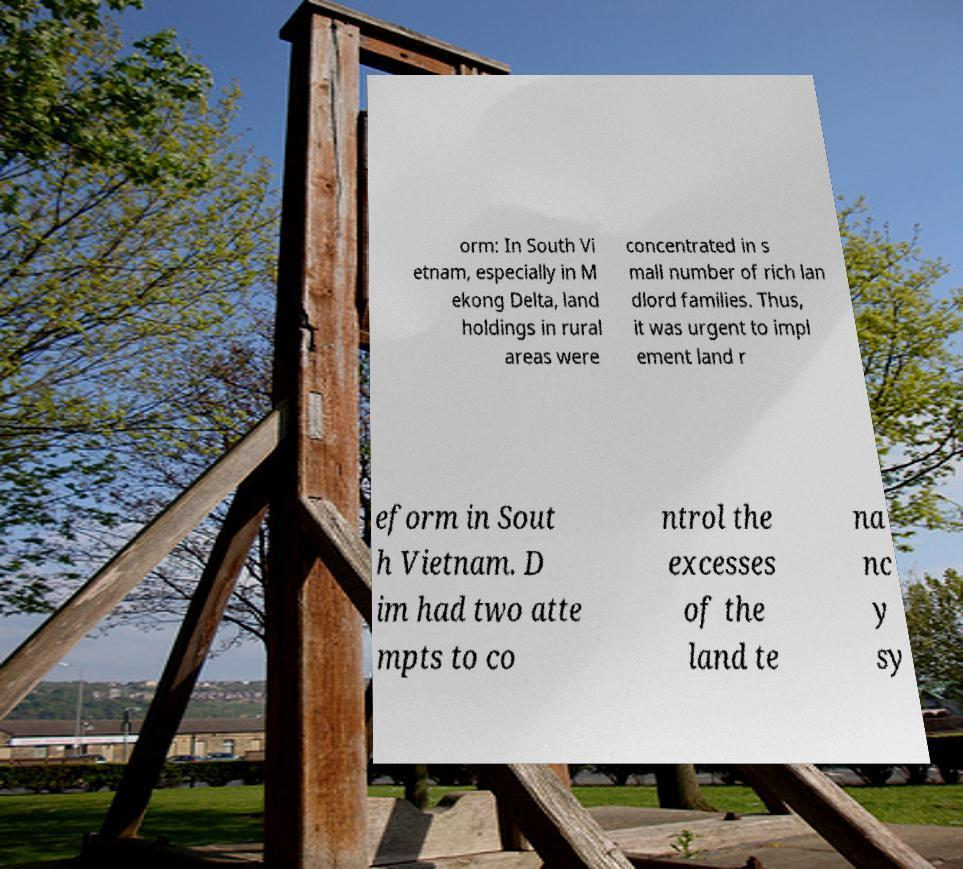Can you accurately transcribe the text from the provided image for me? orm: In South Vi etnam, especially in M ekong Delta, land holdings in rural areas were concentrated in s mall number of rich lan dlord families. Thus, it was urgent to impl ement land r eform in Sout h Vietnam. D im had two atte mpts to co ntrol the excesses of the land te na nc y sy 